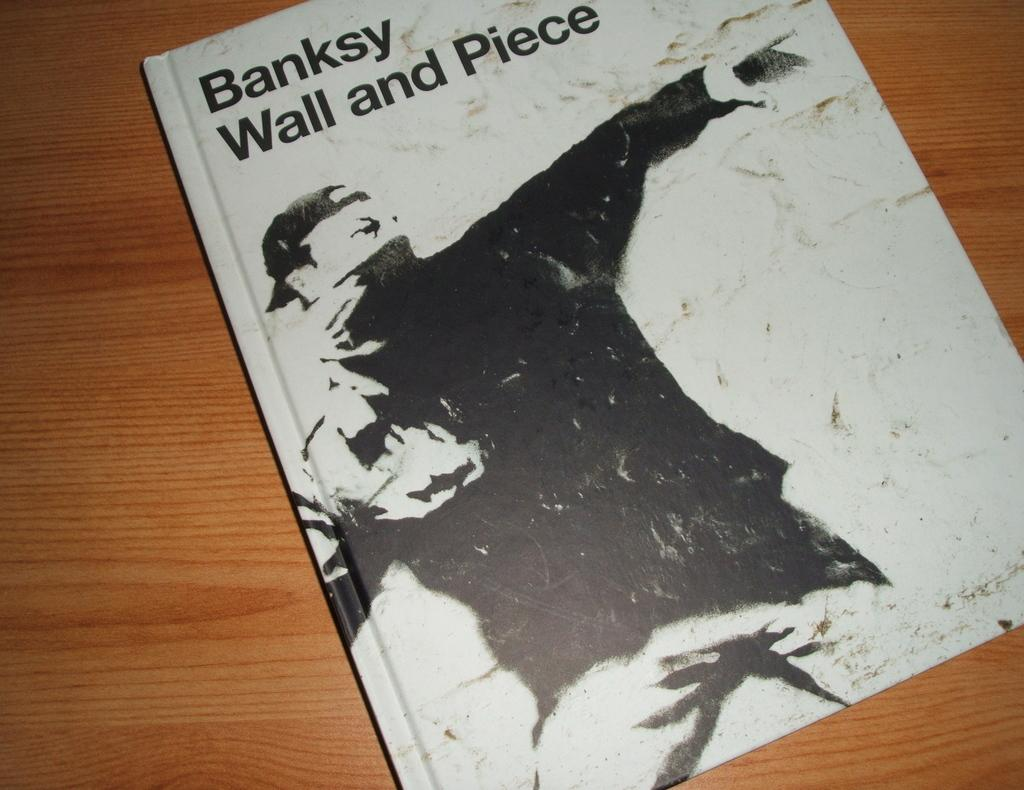<image>
Share a concise interpretation of the image provided. A BLACK AND WHITE BOOK CALLED BANKSY WALL AND PIECE 